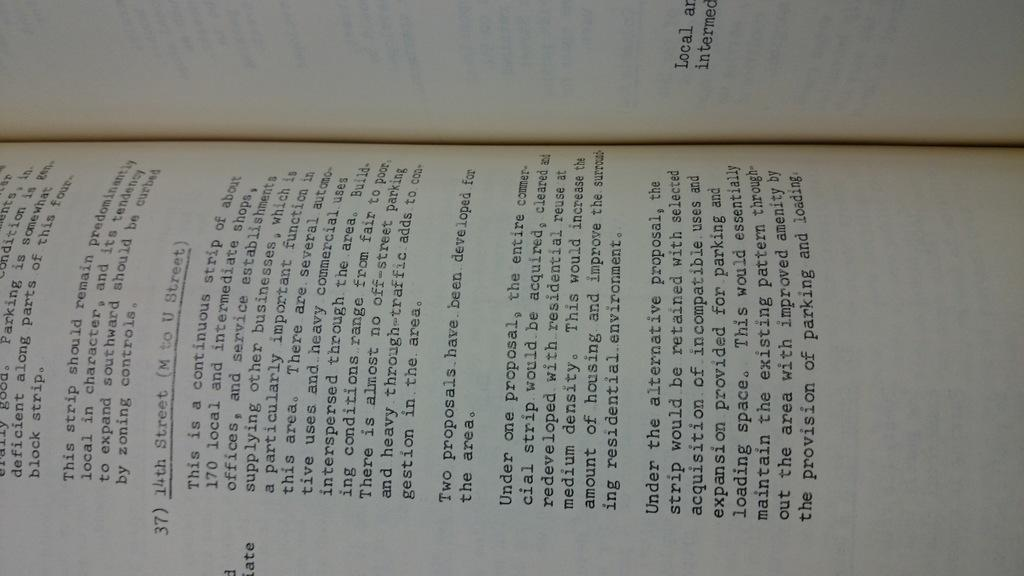<image>
Present a compact description of the photo's key features. 14th street is underlined and preceded by 37 at the middle of the page. 